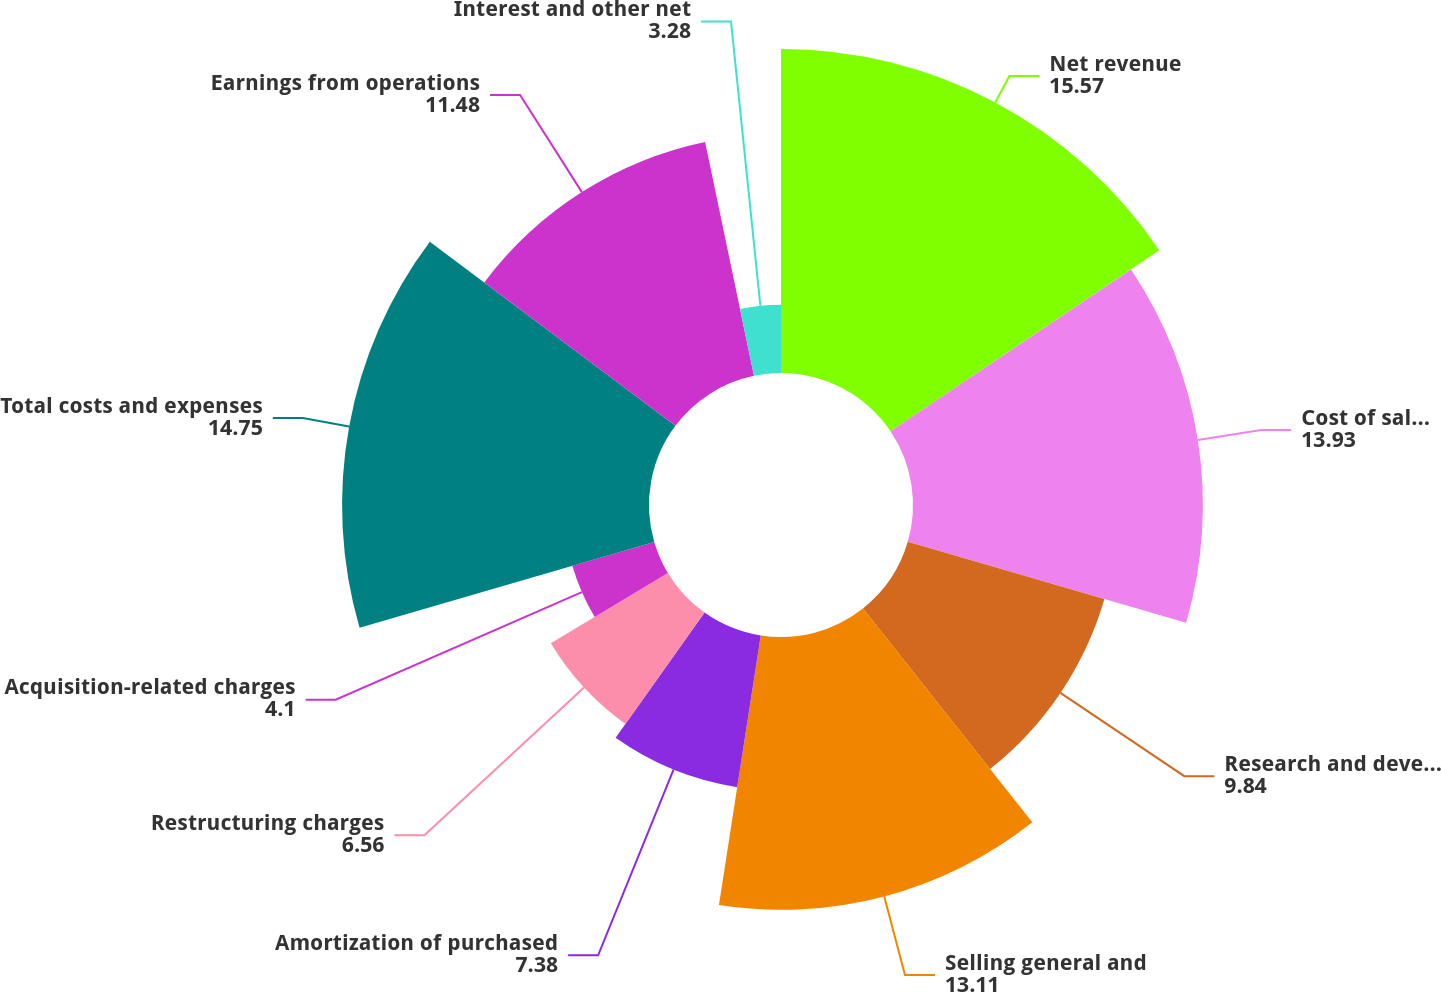<chart> <loc_0><loc_0><loc_500><loc_500><pie_chart><fcel>Net revenue<fcel>Cost of sales (1)<fcel>Research and development<fcel>Selling general and<fcel>Amortization of purchased<fcel>Restructuring charges<fcel>Acquisition-related charges<fcel>Total costs and expenses<fcel>Earnings from operations<fcel>Interest and other net<nl><fcel>15.57%<fcel>13.93%<fcel>9.84%<fcel>13.11%<fcel>7.38%<fcel>6.56%<fcel>4.1%<fcel>14.75%<fcel>11.48%<fcel>3.28%<nl></chart> 